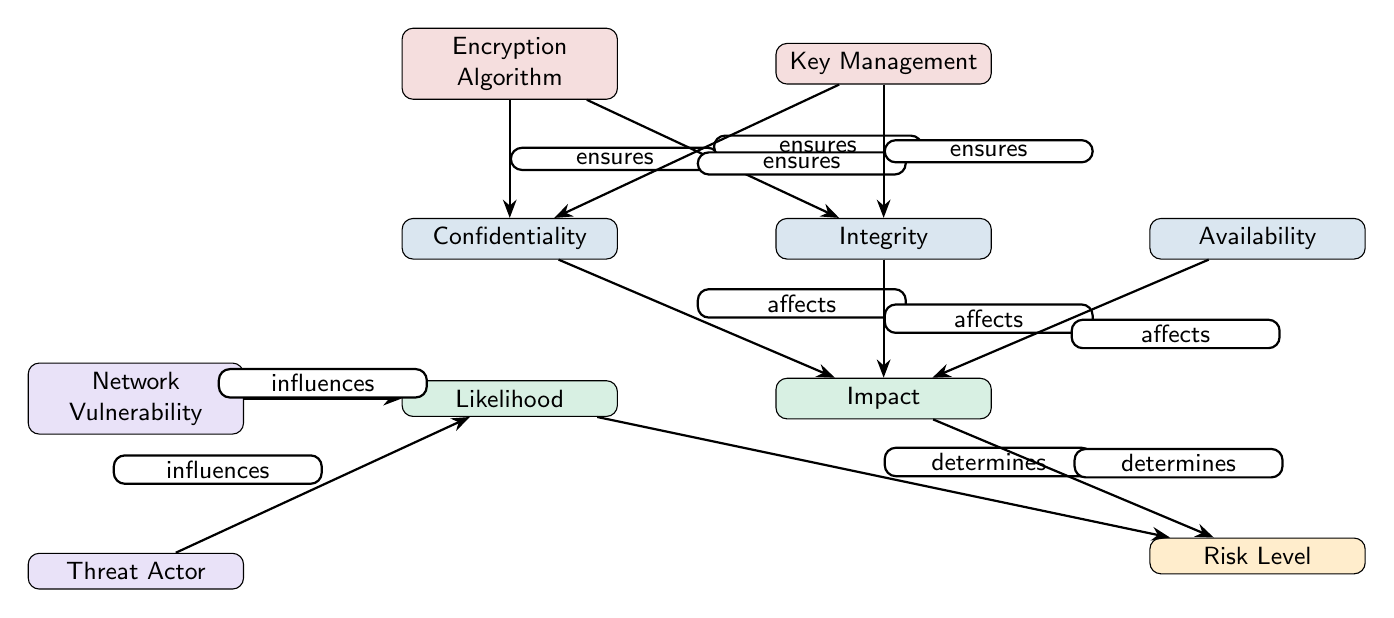What are the three main aspects of secure data transmission depicted in the diagram? The diagram shows three main aspects labeled as Confidentiality, Integrity, and Availability, which are positioned at the top of the diagram.
Answer: Confidentiality, Integrity, Availability How many nodes are present in the diagram? The diagram contains a total of nine nodes: three main aspects, two impact-related nodes, two management-related nodes, and a risk level node.
Answer: Nine What influence does the Network Vulnerability have on the Likelihood? The diagram depicts that Network Vulnerability "influences" the Likelihood, indicating that vulnerabilities in the network can affect how likely a threat is to occur.
Answer: Influences What is the relationship between Encryption and the aspect of Integrity? The Encryption node "ensures" the Integrity aspect, showing that encryption contributes to maintaining data integrity during transmission.
Answer: Ensures What determines the Risk Level according to the diagram? The diagram illustrates that both Likelihood and Impact determine the Risk Level, meaning that these two factors are fundamental in assessing overall risk.
Answer: Likelihood, Impact How does the Threat Actor influence the Likelihood of risk? The diagram shows that the Threat Actor "influences" the Likelihood, suggesting that the presence and actions of threat actors can increase the chances of risks occurring.
Answer: Influences Which nodes ensure Confidentiality according to the diagram? The diagram indicates that both Encryption Algorithm and Key Management ensure Confidentiality, meaning both components are crucial for keeping data secret.
Answer: Encryption Algorithm, Key Management In terms of hierarchy, which aspects are placed above the Risk Level? The diagram places Likelihood and Impact above the Risk Level, showing that these aspects inform the risk assessment process.
Answer: Likelihood, Impact How many edges connect to the Encryption node? The Encryption node has two edges connecting to it: one to Confidentiality and another to Integrity, indicating its role in securing both aspects.
Answer: Two 